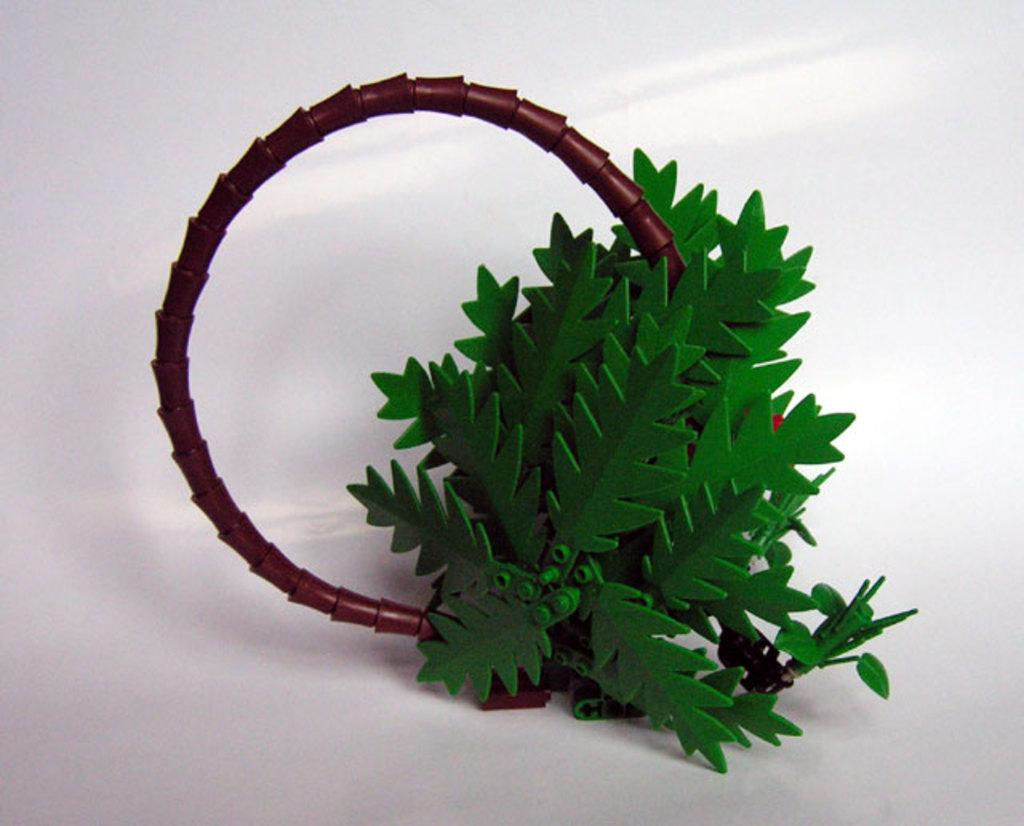What type of vegetation can be seen in the image? There are leaves in the image. What is the color of the surface on which the objects are placed? The surface is white. What type of breakfast is being prepared on the white surface in the image? There is no breakfast or preparation of food visible in the image. Can you see any scissors on the white surface in the image? There is no mention of scissors or any other specific objects on the white surface in the image. 